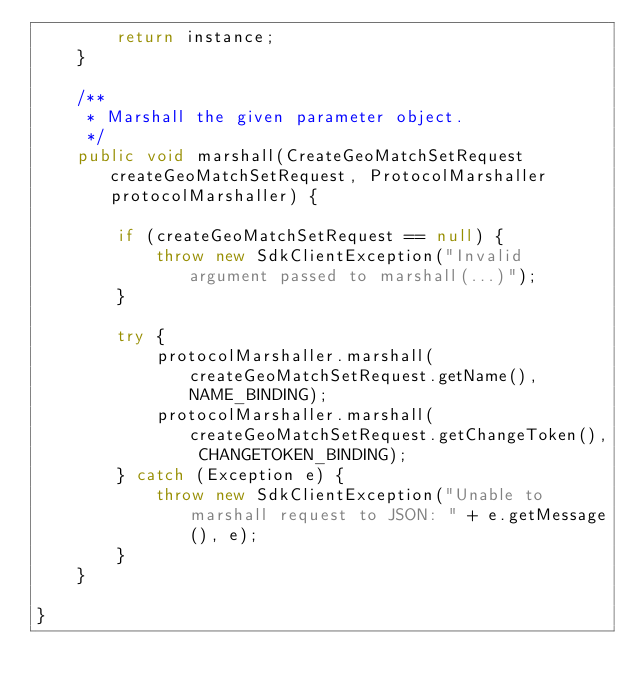Convert code to text. <code><loc_0><loc_0><loc_500><loc_500><_Java_>        return instance;
    }

    /**
     * Marshall the given parameter object.
     */
    public void marshall(CreateGeoMatchSetRequest createGeoMatchSetRequest, ProtocolMarshaller protocolMarshaller) {

        if (createGeoMatchSetRequest == null) {
            throw new SdkClientException("Invalid argument passed to marshall(...)");
        }

        try {
            protocolMarshaller.marshall(createGeoMatchSetRequest.getName(), NAME_BINDING);
            protocolMarshaller.marshall(createGeoMatchSetRequest.getChangeToken(), CHANGETOKEN_BINDING);
        } catch (Exception e) {
            throw new SdkClientException("Unable to marshall request to JSON: " + e.getMessage(), e);
        }
    }

}
</code> 